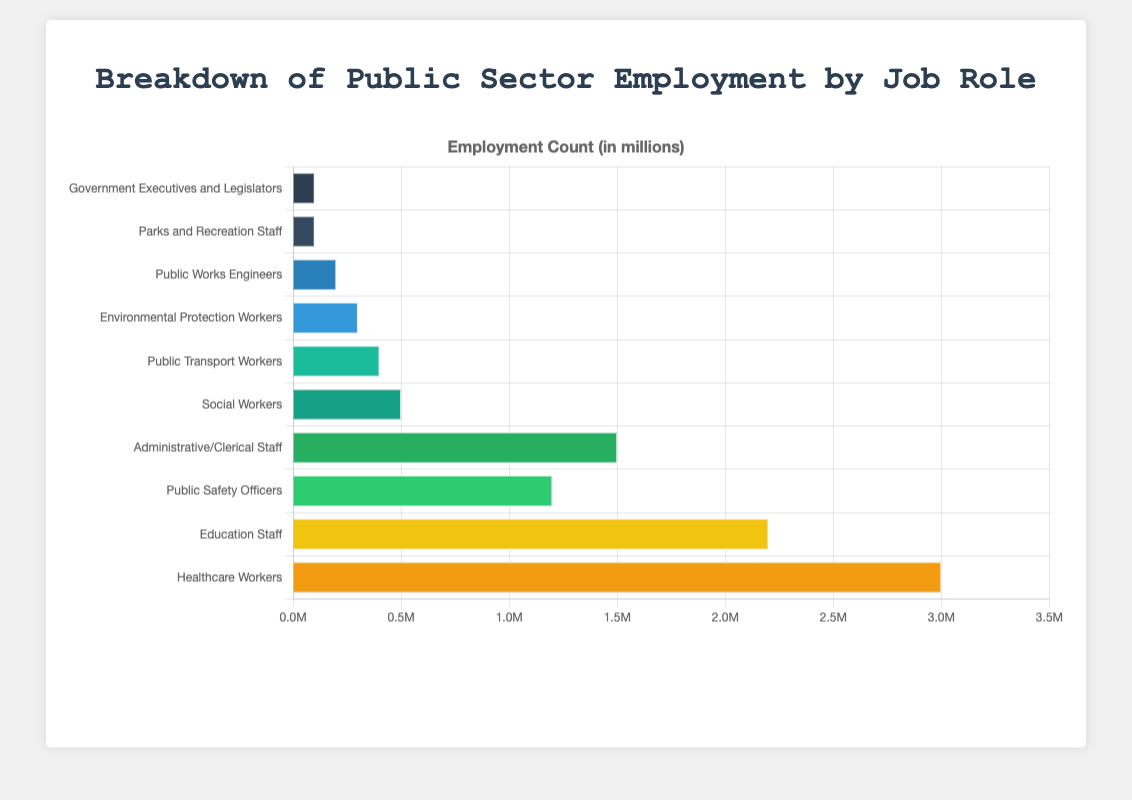Which job role has the highest employment count? The healthcare workers have the highest employment count as represented by the longest bar in the chart.
Answer: Healthcare Workers What is the sum of employment counts for Public Works Engineers, Environmental Protection Workers, and Social Workers? Adding the employment counts for these roles: 200,000 (Public Works Engineers) + 300,000 (Environmental Protection Workers) + 500,000 (Social Workers) equals 1,000,000.
Answer: 1,000,000 How much higher is the employment count for Education Staff compared to Public Safety Officers? The employment count for Education Staff is 2,200,000, and for Public Safety Officers, it is 1,200,000. The difference is 2,200,000 - 1,200,000 = 1,000,000.
Answer: 1,000,000 Which job role has an employment count exactly one-fifth of Healthcare Workers? One-fifth of Healthcare Workers' employment count (3,000,000) is 600,000, and Social Workers have an employment count of 500,000, which is close but not exact. Therefore, there is no role with exactly one-fifth.
Answer: None Which sectors have less than 500,000 employees? Sectors with bars representing values less than 500,000 are Parks and Recreation Staff, Government Executives and Legislators, Public Works Engineers, Environmental Protection Workers, and Public Transport Workers.
Answer: Parks and Recreation Staff, Government Executives and Legislators, Public Works Engineers, Environmental Protection Workers, Public Transport Workers What is the employment count range of the data presented? The lowest employment count is for 'Government Executives and Legislators' and 'Parks and Recreation Staff' both having 100,000, and the highest is for 'Healthcare Workers' at 3,000,000. The range is calculated as 3,000,000 - 100,000 = 2,900,000.
Answer: 2,900,000 Which job roles have employment counts that are within 100,000 of each other? Administrative/Clerical Staff (1,500,000) and Public Safety Officers (1,200,000) are within 300,000 of each other but not within 100,000. Government Executives and Legislators (100,000) and Parks and Recreation Staff (100,000) have the same count within 100,000.
Answer: Government Executives and Legislators, Parks and Recreation Staff What is the median employment count for the job roles listed? Sorting the employment counts: 100,000, 100,000, 200,000, 300,000, 400,000, 500,000, 1,200,000, 1,500,000, 2,200,000, 3,000,000. With 10 data points, the median is the average of the 5th and 6th values: (400,000 + 500,000) / 2 = 450,000.
Answer: 450,000 Which color bar represents the Public Transport Workers? The Public Transport Workers are represented by the fifth bar from the bottom which appears greenish.
Answer: Green 